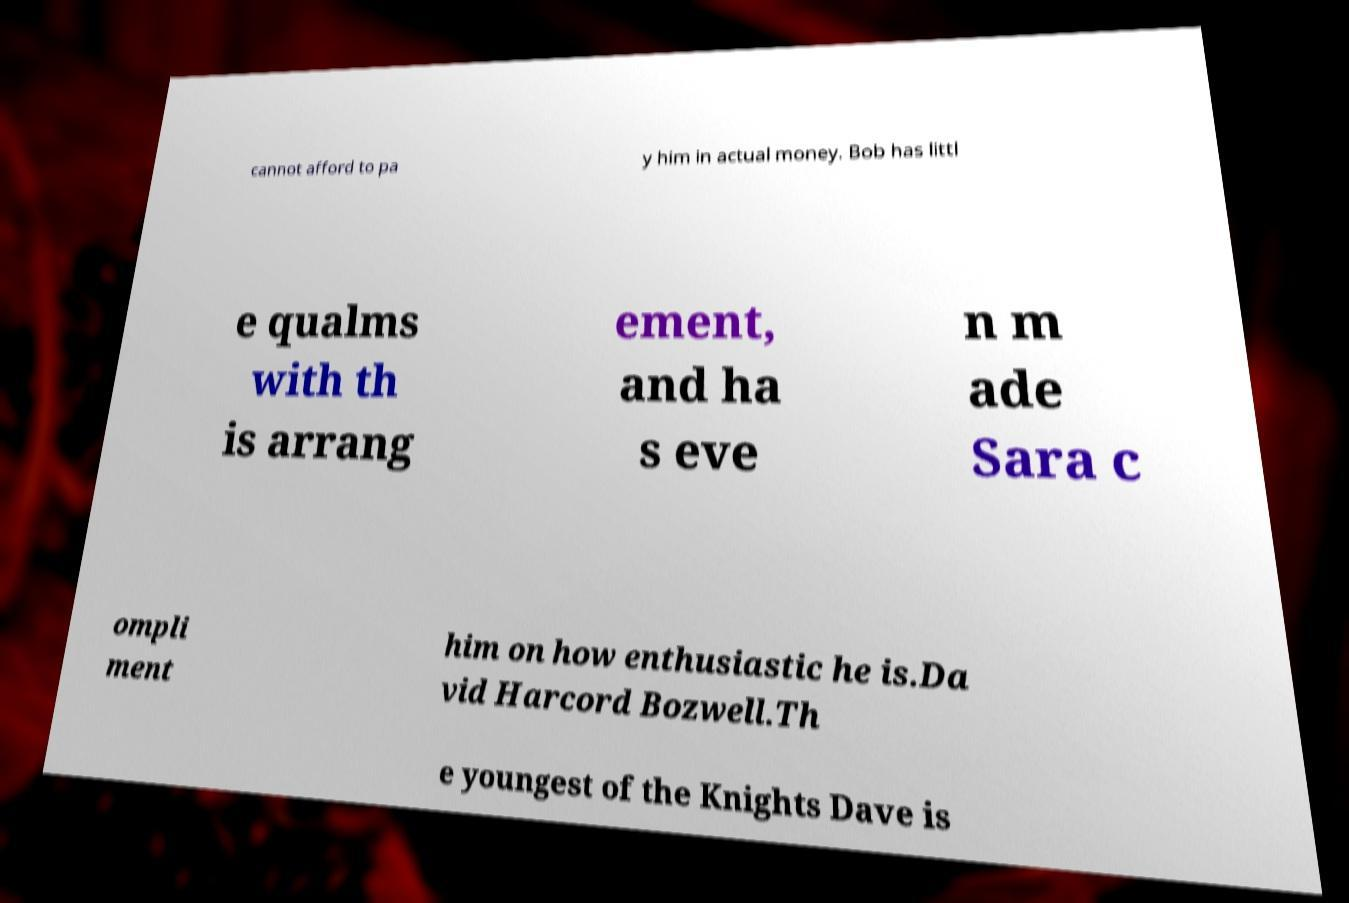Could you assist in decoding the text presented in this image and type it out clearly? cannot afford to pa y him in actual money. Bob has littl e qualms with th is arrang ement, and ha s eve n m ade Sara c ompli ment him on how enthusiastic he is.Da vid Harcord Bozwell.Th e youngest of the Knights Dave is 